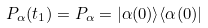<formula> <loc_0><loc_0><loc_500><loc_500>P _ { \alpha } ( t _ { 1 } ) = P _ { \alpha } = | \alpha ( 0 ) \rangle \langle \alpha ( 0 ) |</formula> 